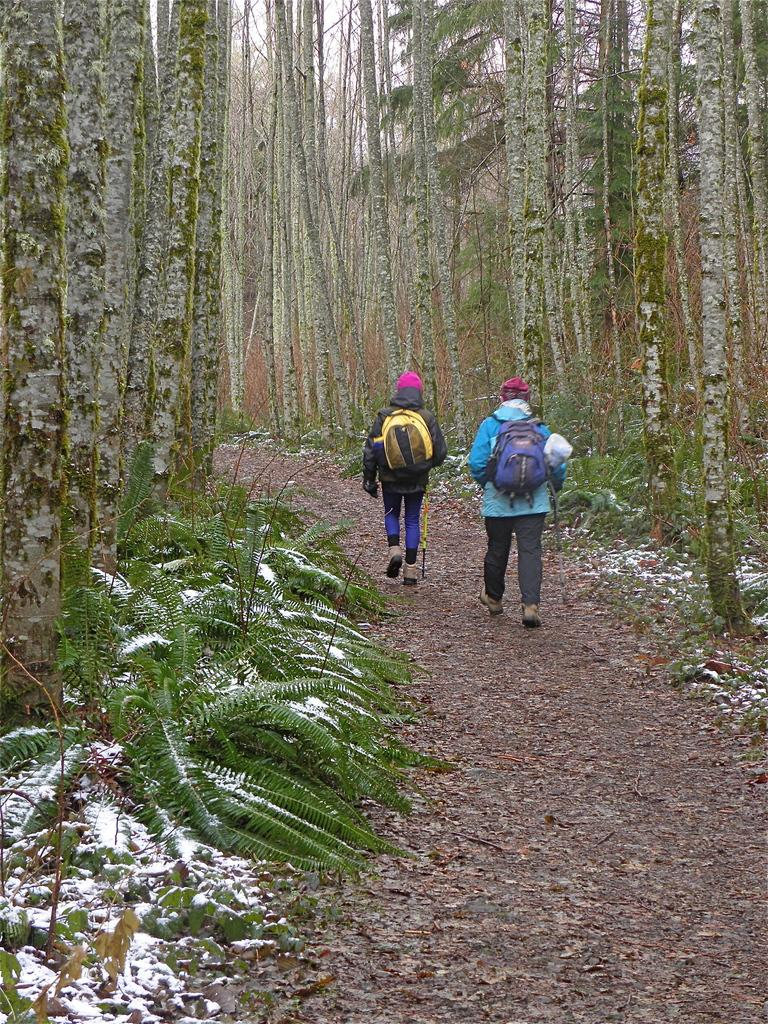How many people are in the image? There are two persons in the image. What are the persons wearing? The persons are wearing bags. What are the persons holding in their hands? The persons are holding sticks. What is the surface they are walking on? The persons are walking on the ground. What type of vegetation can be seen in the image? There are plants and trees in the image. What is the weather like in the image? There is snow visible in the image, indicating a cold or wintry environment. What type of flower can be seen blooming in the image? There is no flower present in the image; it features two persons wearing bags, holding sticks, and walking on the ground amidst snow and trees. Can you hear the persons talking in the image? The image is a still picture, so it does not capture any sounds or conversations. 